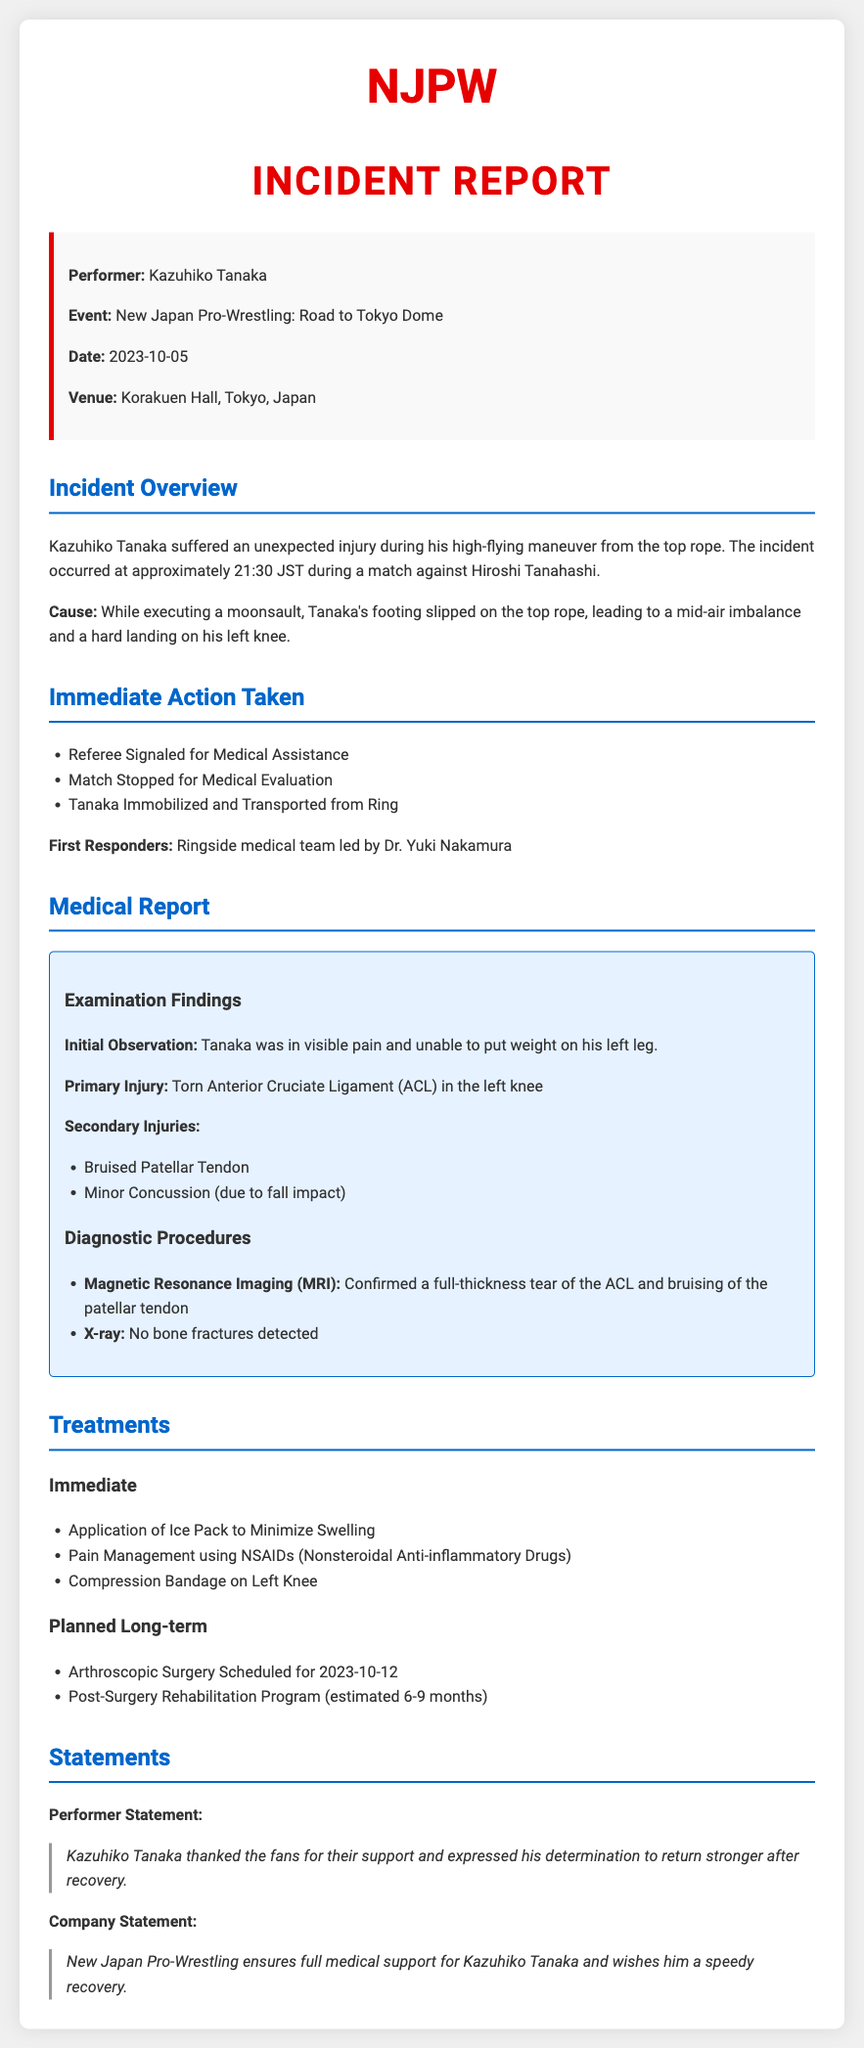What is the performer's name? The performer's name is mentioned in the incident details section of the document.
Answer: Kazuhiko Tanaka What event was Kazuhiko Tanaka performing in? The document specifies the event during which the incident occurred.
Answer: New Japan Pro-Wrestling: Road to Tokyo Dome What date did the incident occur? The document clearly states the date of the incident.
Answer: 2023-10-05 What was the primary injury suffered by Kazuhiko Tanaka? The medical report outlines the primary injury sustained during the performance.
Answer: Torn Anterior Cruciate Ligament (ACL) What immediate action was taken after the injury? The document lists the immediate actions taken following the injury.
Answer: Medical Assistance What diagnostic procedure confirmed the injury? The medical report details the diagnostic procedures conducted following the incident.
Answer: Magnetic Resonance Imaging (MRI) How long is the estimated recovery time for Tanaka? The document mentions the estimated recovery time in terms of months.
Answer: 6-9 months What is scheduled for October 12, 2023? The planned long-term treatment section of the document provides this information.
Answer: Arthroscopic Surgery What did Kazuhiko Tanaka express in his statement? The document includes Tanaka's statement to the fans regarding his future.
Answer: Determination to return stronger 